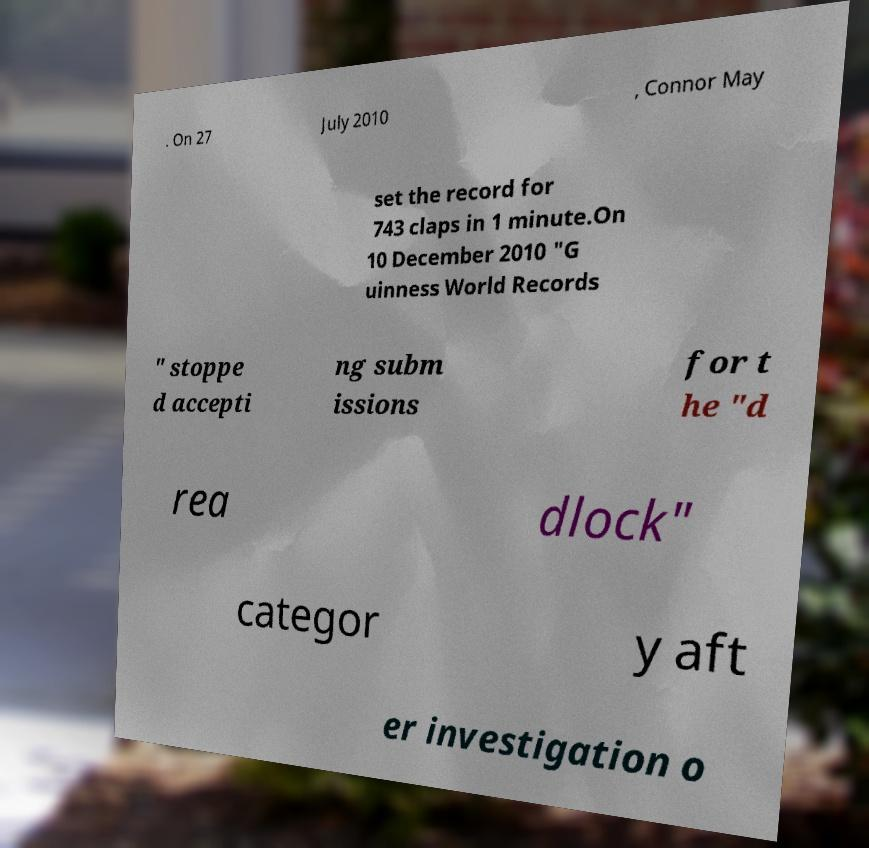Can you accurately transcribe the text from the provided image for me? . On 27 July 2010 , Connor May set the record for 743 claps in 1 minute.On 10 December 2010 "G uinness World Records " stoppe d accepti ng subm issions for t he "d rea dlock" categor y aft er investigation o 